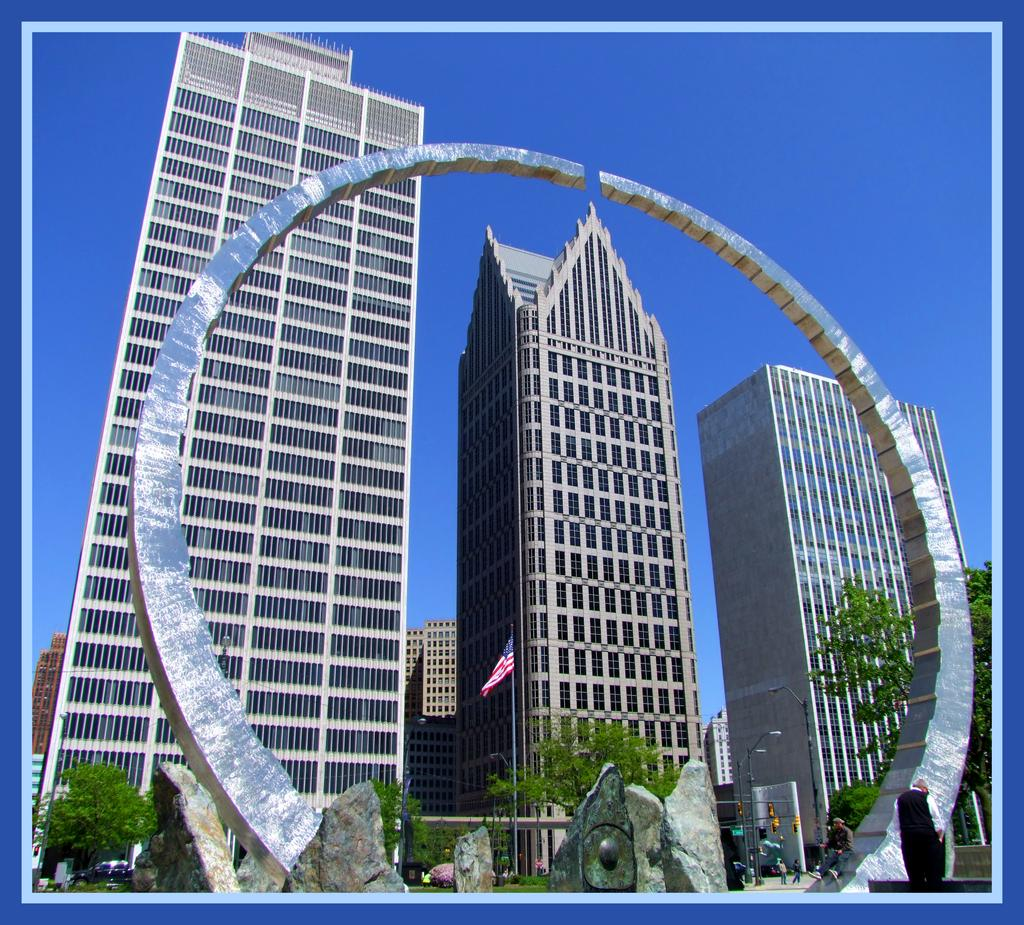What type of buildings can be seen in the image? There are skyscrapers in the image. What kind of artwork is present in the image? There are sculptures in the image. What architectural feature is visible in the image? There is an arch in the image. What symbol can be seen in the image? There is a flag in the image. What structure is holding the flag in the image? There is a flag post in the image. Who or what is present in the image? There are persons in the image. What mode of transportation can be seen in the image? There are motor vehicles in the image. What type of vegetation is visible in the image? There are trees in the image. Who is wearing a crown in the image? There is no crown present in the image. How many friends are visible in the image? The term "friends" is not mentioned in the provided facts, and therefore it cannot be determined from the image. What level of expertise does the beginner have in the image? The term "beginner" is not mentioned in the provided facts, and therefore it cannot be determined from the image. 